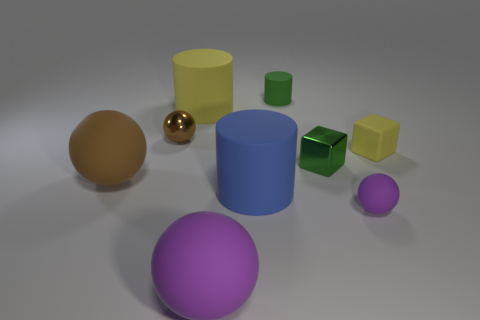There is a small shiny sphere; does it have the same color as the large sphere that is behind the blue rubber cylinder?
Your response must be concise. Yes. There is a thing that is the same color as the metal block; what shape is it?
Provide a short and direct response. Cylinder. What is the big cylinder that is behind the sphere that is behind the cube in front of the rubber block made of?
Provide a short and direct response. Rubber. There is a metal object that is to the left of the small matte cylinder; is it the same shape as the big purple object?
Provide a succinct answer. Yes. There is a tiny sphere behind the small purple matte ball; what is its material?
Provide a succinct answer. Metal. How many rubber things are green balls or tiny things?
Your answer should be compact. 3. Is there another object that has the same size as the blue object?
Ensure brevity in your answer.  Yes. Is the number of small matte things behind the big brown object greater than the number of brown metallic balls?
Your answer should be very brief. Yes. How many big things are either yellow cylinders or brown spheres?
Give a very brief answer. 2. What number of small yellow rubber things are the same shape as the green metal thing?
Your answer should be compact. 1. 